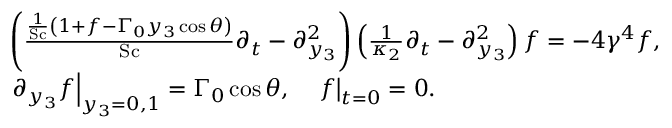Convert formula to latex. <formula><loc_0><loc_0><loc_500><loc_500>\begin{array} { r l } & { \left ( \frac { \frac { 1 } { S c } \left ( 1 + f - \Gamma _ { 0 } y _ { 3 } \cos \theta \right ) } { S c } \partial _ { t } - \partial _ { y _ { 3 } } ^ { 2 } \right ) \left ( \frac { 1 } { \kappa _ { 2 } } \partial _ { t } - \partial _ { y _ { 3 } } ^ { 2 } \right ) f = - 4 \gamma ^ { 4 } f , } \\ & { \partial _ { y _ { 3 } } f \right | _ { y _ { 3 } = 0 , 1 } = \Gamma _ { 0 } \cos \theta , \quad f \right | _ { t = 0 } = 0 . } \end{array}</formula> 